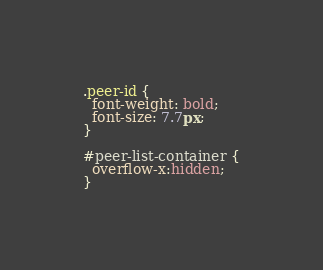Convert code to text. <code><loc_0><loc_0><loc_500><loc_500><_CSS_>.peer-id {
  font-weight: bold;
  font-size: 7.7px;
}

#peer-list-container {
  overflow-x:hidden;
}
</code> 